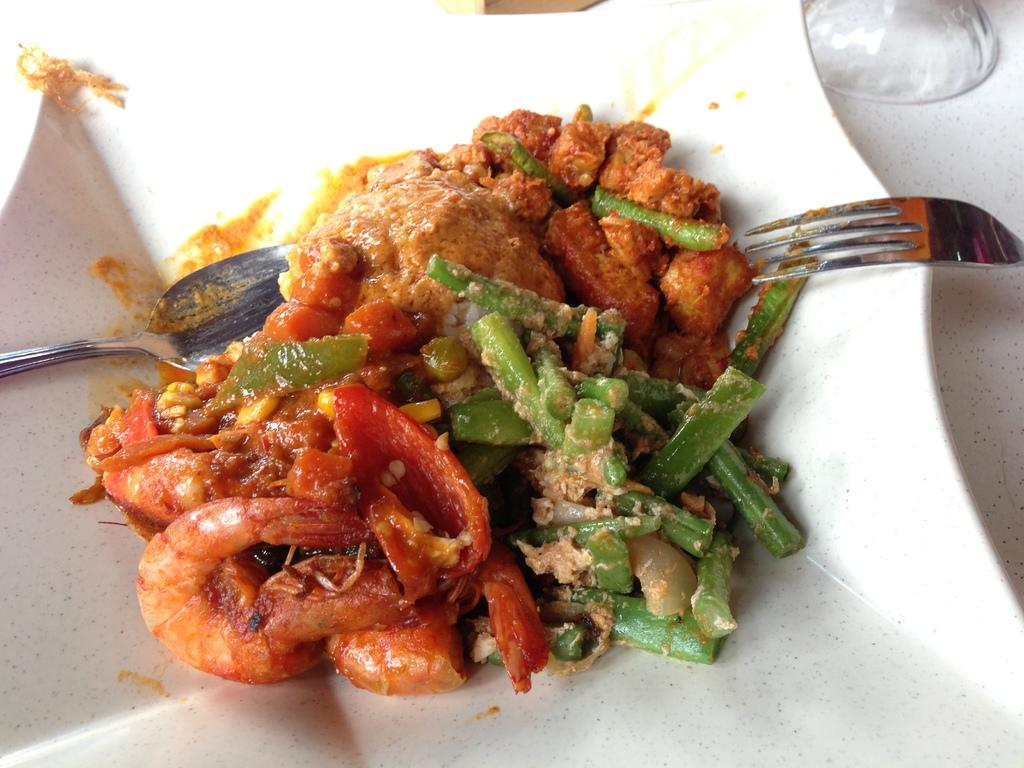What utensils are visible in the image? There is a spoon and a fork in the image. What is the food item placed on in the image? The food item is placed on a plate in the image. What is located on the right side of the image? There is a glass on the right side of the image. What piece of furniture is present in the image? There is a table in the image. What type of wound can be seen on the table in the image? There is no wound present in the image; it features a table with utensils, a plate, a glass, and a food item. 